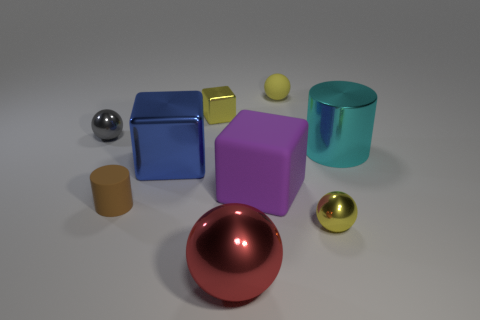There is a rubber object that is the same color as the small block; what is its size?
Offer a very short reply. Small. How many objects are blue metal cylinders or small rubber objects in front of the big blue metallic thing?
Ensure brevity in your answer.  1. The metallic object that is left of the large cylinder and on the right side of the big red shiny thing is what color?
Provide a short and direct response. Yellow. Does the purple cube have the same size as the matte cylinder?
Your answer should be very brief. No. There is a rubber object left of the yellow block; what color is it?
Give a very brief answer. Brown. Is there a block of the same color as the small matte ball?
Give a very brief answer. Yes. There is a block that is the same size as the rubber cylinder; what color is it?
Make the answer very short. Yellow. Do the tiny gray thing and the large red metal object have the same shape?
Give a very brief answer. Yes. What is the material of the yellow thing that is in front of the gray metallic thing?
Your answer should be very brief. Metal. What is the color of the matte cylinder?
Your answer should be very brief. Brown. 